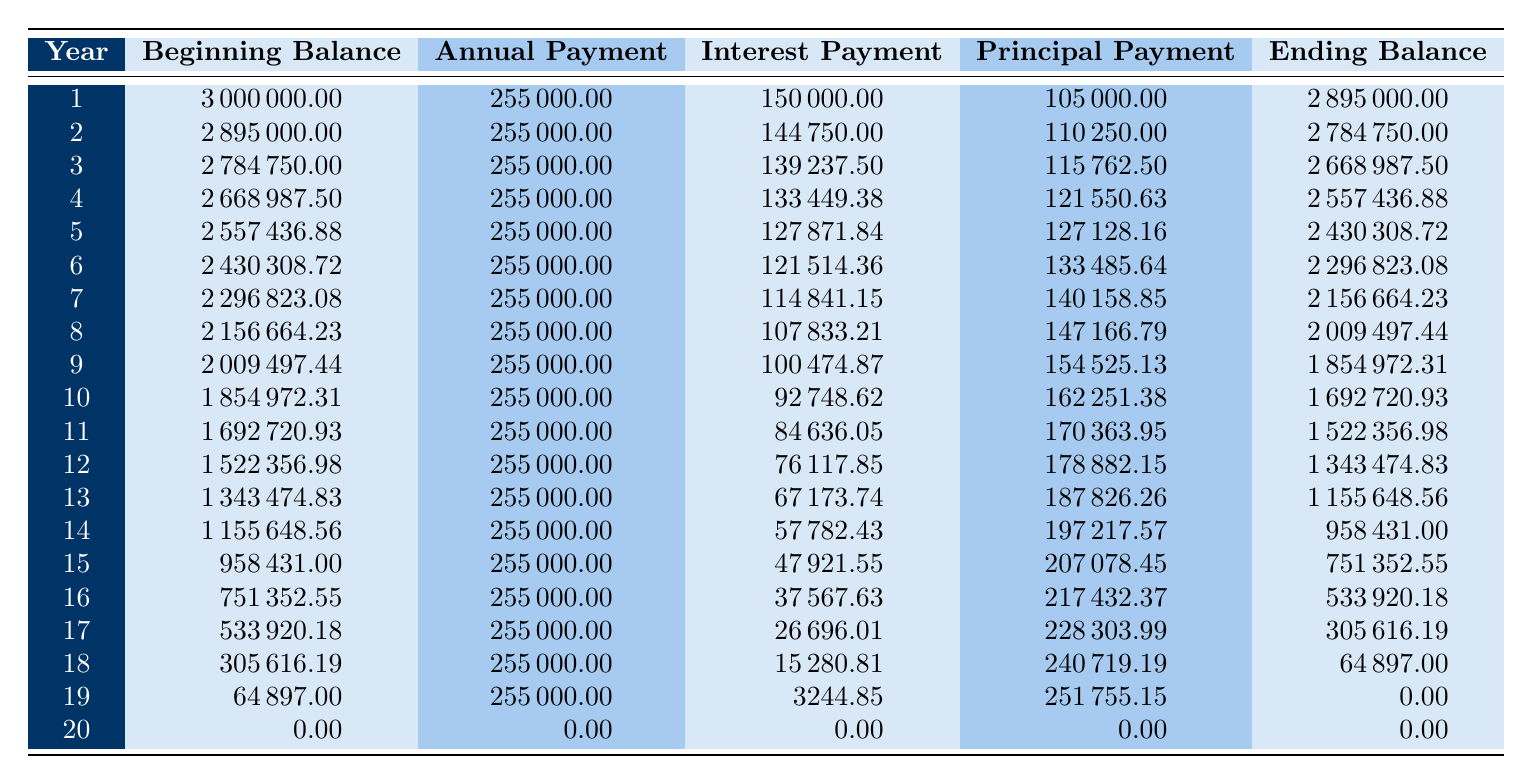What is the total investment cost for the Solar Farm Project in Romania? The table states that the total investment cost is clearly mentioned at the beginning, listed under the investment details as 3000000.00.
Answer: 3000000.00 What was the annual payment in year 5? In the table, under the row for year 5, the annual payment is clearly indicated as 255000.00.
Answer: 255000.00 What is the principal payment for year 10? For year 10, the principal payment is found in the table under that year, which is listed as 162251.38.
Answer: 162251.38 How much interest was paid in total over the first five years? The interest payments for the first five years are: 150000.00 (year 1) + 144750.00 (year 2) + 139237.50 (year 3) + 133449.38 (year 4) + 127871.84 (year 5) = 695308.72. Adding these amounts gives a total of 695308.72.
Answer: 695308.72 Is the ending balance in year 19 zero? Looking at the table, the ending balance for year 19 is listed as 0.00, which confirms that it is indeed zero.
Answer: Yes 